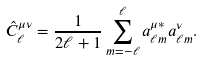Convert formula to latex. <formula><loc_0><loc_0><loc_500><loc_500>\hat { C } _ { \ell } ^ { \mu \nu } = \frac { 1 } { 2 \ell + 1 } \sum ^ { \ell } _ { m = - \ell } a ^ { \mu * } _ { \ell m } a ^ { \nu } _ { \ell m } .</formula> 